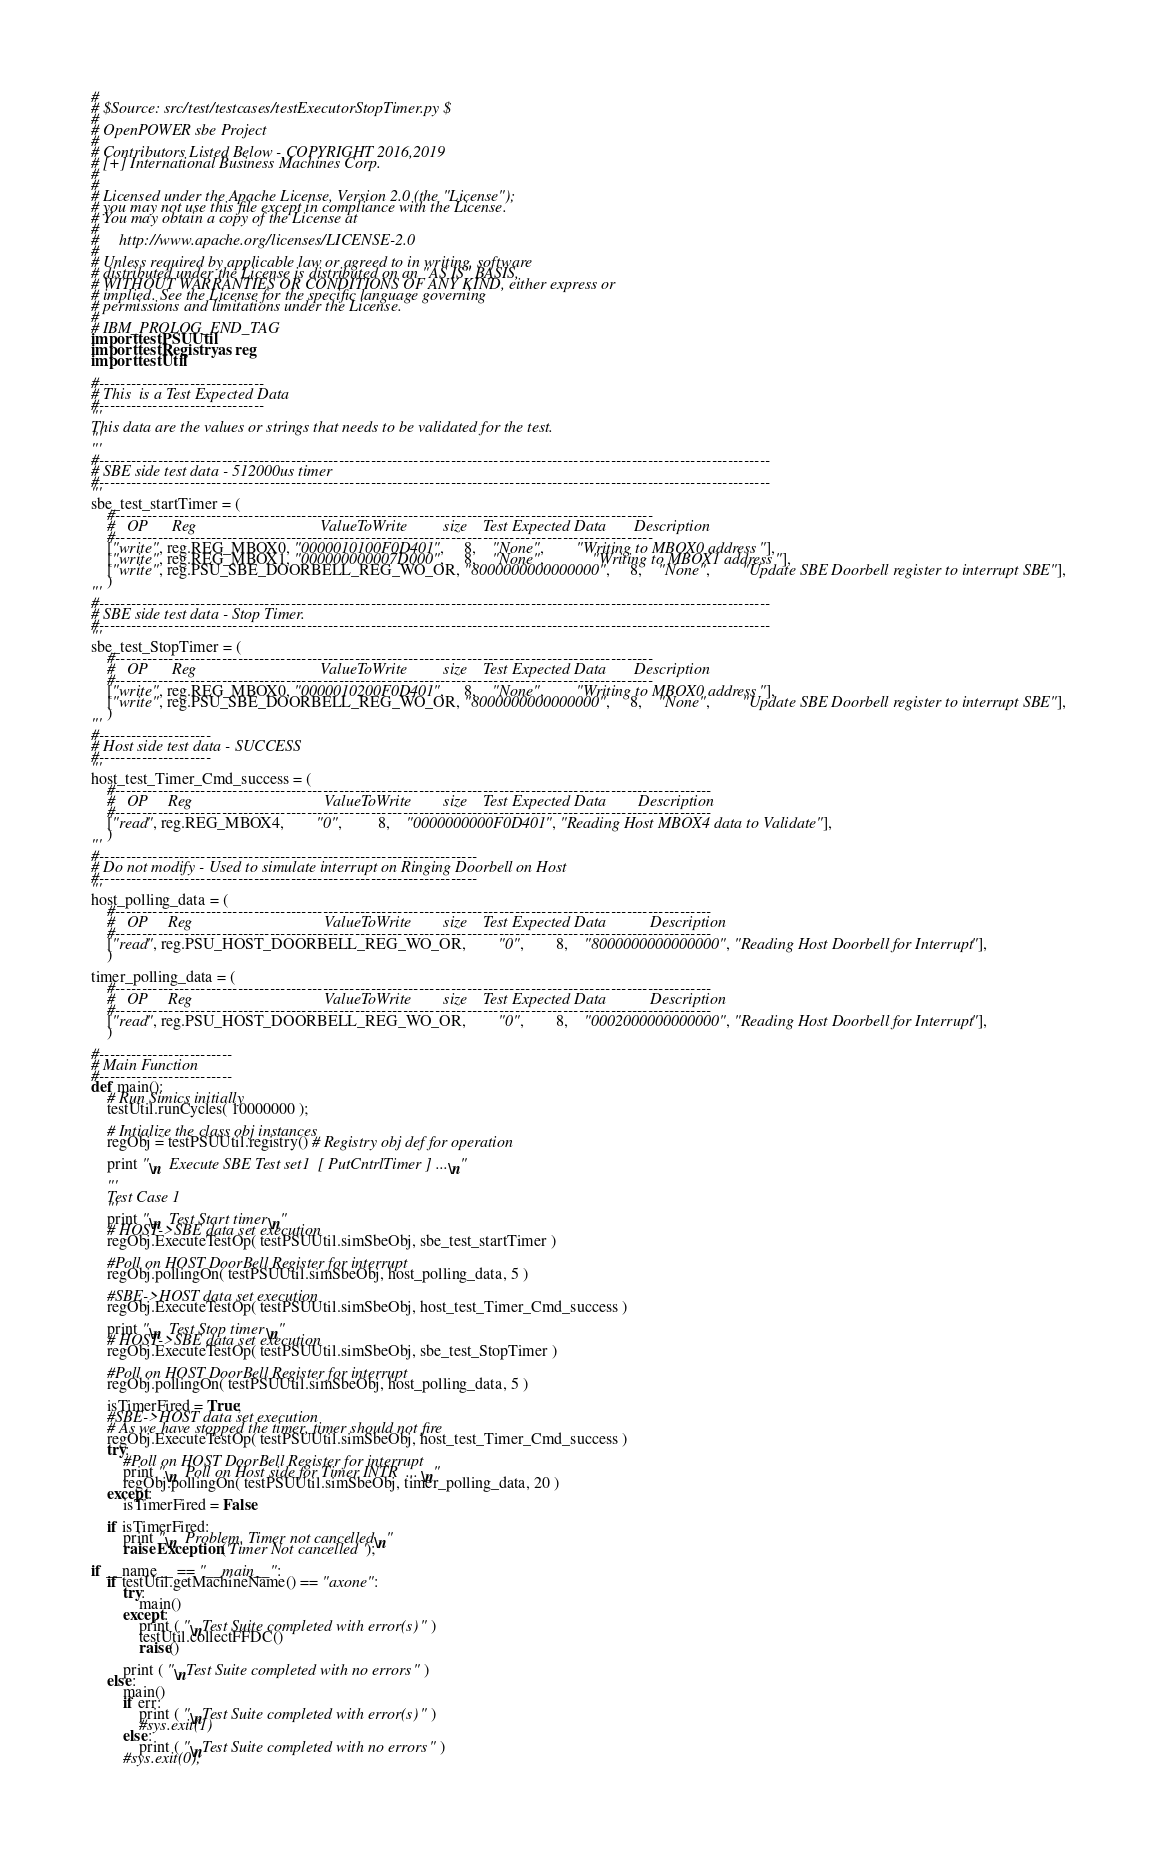Convert code to text. <code><loc_0><loc_0><loc_500><loc_500><_Python_>#
# $Source: src/test/testcases/testExecutorStopTimer.py $
#
# OpenPOWER sbe Project
#
# Contributors Listed Below - COPYRIGHT 2016,2019
# [+] International Business Machines Corp.
#
#
# Licensed under the Apache License, Version 2.0 (the "License");
# you may not use this file except in compliance with the License.
# You may obtain a copy of the License at
#
#     http://www.apache.org/licenses/LICENSE-2.0
#
# Unless required by applicable law or agreed to in writing, software
# distributed under the License is distributed on an "AS IS" BASIS,
# WITHOUT WARRANTIES OR CONDITIONS OF ANY KIND, either express or
# implied. See the License for the specific language governing
# permissions and limitations under the License.
#
# IBM_PROLOG_END_TAG
import testPSUUtil
import testRegistry as reg
import testUtil

#-------------------------------
# This  is a Test Expected Data
#-------------------------------
'''
This data are the values or strings that needs to be validated for the test.
'''
'''
#------------------------------------------------------------------------------------------------------------------------------
# SBE side test data - 512000us timer
#------------------------------------------------------------------------------------------------------------------------------
'''
sbe_test_startTimer = (
    #-----------------------------------------------------------------------------------------------------
    #   OP      Reg                               ValueToWrite         size    Test Expected Data       Description
    #-----------------------------------------------------------------------------------------------------
    ["write", reg.REG_MBOX0, "0000010100F0D401", 	 8, 	"None", 		"Writing to MBOX0 address"],
    ["write", reg.REG_MBOX1, "000000000007D000", 	 8, 	"None", 			"Writing to MBOX1 address"],
    ["write", reg.PSU_SBE_DOORBELL_REG_WO_OR, "8000000000000000", 	 8, 	"None", 		"Update SBE Doorbell register to interrupt SBE"],
    )
'''
#------------------------------------------------------------------------------------------------------------------------------
# SBE side test data - Stop Timer.
#------------------------------------------------------------------------------------------------------------------------------
'''
sbe_test_StopTimer = (
    #-----------------------------------------------------------------------------------------------------
    #   OP      Reg                               ValueToWrite         size    Test Expected Data       Description
    #-----------------------------------------------------------------------------------------------------
    ["write", reg.REG_MBOX0, "0000010200F0D401", 	 8, 	"None", 		"Writing to MBOX0 address"],
    ["write", reg.PSU_SBE_DOORBELL_REG_WO_OR, "8000000000000000", 	 8, 	"None", 		"Update SBE Doorbell register to interrupt SBE"],
    )
'''
#---------------------
# Host side test data - SUCCESS
#---------------------
'''
host_test_Timer_Cmd_success = (
    #----------------------------------------------------------------------------------------------------------------
    #   OP     Reg                                 ValueToWrite        size    Test Expected Data        Description
    #----------------------------------------------------------------------------------------------------------------
    ["read", reg.REG_MBOX4, 		"0", 	 	 8, 	"0000000000F0D401", "Reading Host MBOX4 data to Validate"],
    )
'''
#-----------------------------------------------------------------------
# Do not modify - Used to simulate interrupt on Ringing Doorbell on Host
#-----------------------------------------------------------------------
'''
host_polling_data = (
    #----------------------------------------------------------------------------------------------------------------
    #   OP     Reg                                 ValueToWrite        size    Test Expected Data           Description
    #----------------------------------------------------------------------------------------------------------------
    ["read", reg.PSU_HOST_DOORBELL_REG_WO_OR, 		"0", 		8, 	"8000000000000000", "Reading Host Doorbell for Interrupt"],
    )

timer_polling_data = (
    #----------------------------------------------------------------------------------------------------------------
    #   OP     Reg                                 ValueToWrite        size    Test Expected Data           Description
    #----------------------------------------------------------------------------------------------------------------
    ["read", reg.PSU_HOST_DOORBELL_REG_WO_OR, 		"0", 		8, 	"0002000000000000", "Reading Host Doorbell for Interrupt"],
    )

#-------------------------
# Main Function
#-------------------------
def main():
    # Run Simics initially
    testUtil.runCycles( 10000000 );

    # Intialize the class obj instances
    regObj = testPSUUtil.registry() # Registry obj def for operation

    print "\n  Execute SBE Test set1  [ PutCntrlTimer ] ...\n"

    '''
    Test Case 1
    '''
    print "\n  Test Start timer\n"
    # HOST->SBE data set execution
    regObj.ExecuteTestOp( testPSUUtil.simSbeObj, sbe_test_startTimer )

    #Poll on HOST DoorBell Register for interrupt
    regObj.pollingOn( testPSUUtil.simSbeObj, host_polling_data, 5 )

    #SBE->HOST data set execution
    regObj.ExecuteTestOp( testPSUUtil.simSbeObj, host_test_Timer_Cmd_success )

    print "\n  Test Stop timer\n"
    # HOST->SBE data set execution
    regObj.ExecuteTestOp( testPSUUtil.simSbeObj, sbe_test_StopTimer )

    #Poll on HOST DoorBell Register for interrupt
    regObj.pollingOn( testPSUUtil.simSbeObj, host_polling_data, 5 )

    isTimerFired = True;
    #SBE->HOST data set execution
    # As we have stopped the timer, timer should not fire
    regObj.ExecuteTestOp( testPSUUtil.simSbeObj, host_test_Timer_Cmd_success )
    try:
        #Poll on HOST DoorBell Register for interrupt
        print "\n  Poll on Host side for Timer INTR  ...\n"
        regObj.pollingOn( testPSUUtil.simSbeObj, timer_polling_data, 20 )
    except:
        isTimerFired = False

    if isTimerFired:
        print "\n  Problem. Timer not cancelled\n"
        raise Exception('Timer Not cancelled ');

if __name__ == "__main__":
    if testUtil.getMachineName() == "axone":
        try:
            main()
        except:
            print ( "\nTest Suite completed with error(s)" )
            testUtil.collectFFDC()
            raise()

        print ( "\nTest Suite completed with no errors" )
    else:
        main()
        if err:
            print ( "\nTest Suite completed with error(s)" )
            #sys.exit(1)
        else:
            print ( "\nTest Suite completed with no errors" )
        #sys.exit(0);


</code> 